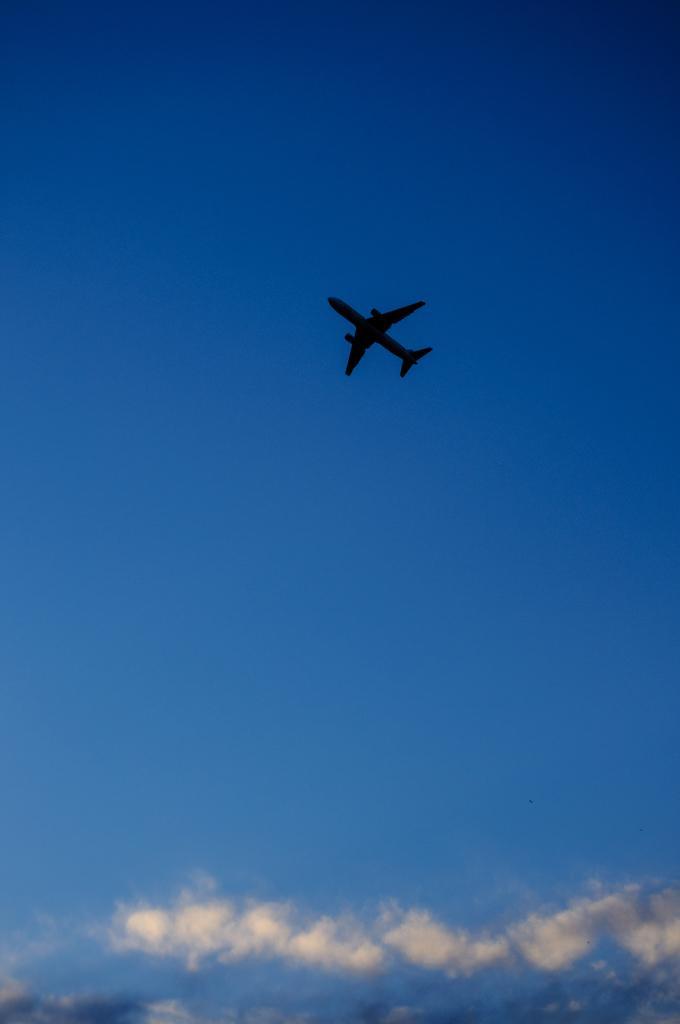In one or two sentences, can you explain what this image depicts? In the picture we can see a flight in the air behind it, we can see the sky with clouds. 